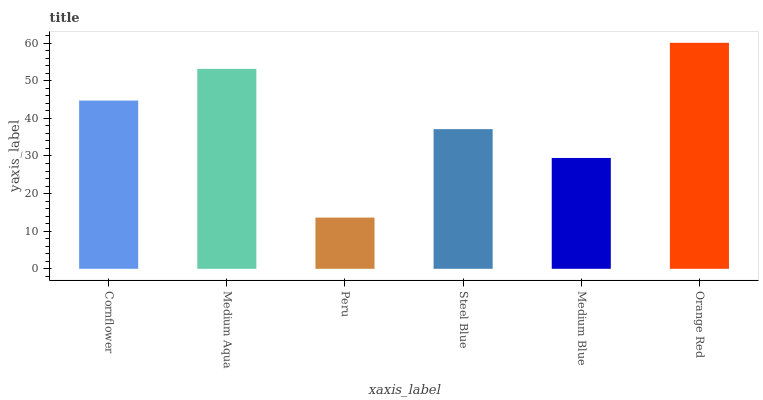Is Peru the minimum?
Answer yes or no. Yes. Is Orange Red the maximum?
Answer yes or no. Yes. Is Medium Aqua the minimum?
Answer yes or no. No. Is Medium Aqua the maximum?
Answer yes or no. No. Is Medium Aqua greater than Cornflower?
Answer yes or no. Yes. Is Cornflower less than Medium Aqua?
Answer yes or no. Yes. Is Cornflower greater than Medium Aqua?
Answer yes or no. No. Is Medium Aqua less than Cornflower?
Answer yes or no. No. Is Cornflower the high median?
Answer yes or no. Yes. Is Steel Blue the low median?
Answer yes or no. Yes. Is Steel Blue the high median?
Answer yes or no. No. Is Peru the low median?
Answer yes or no. No. 